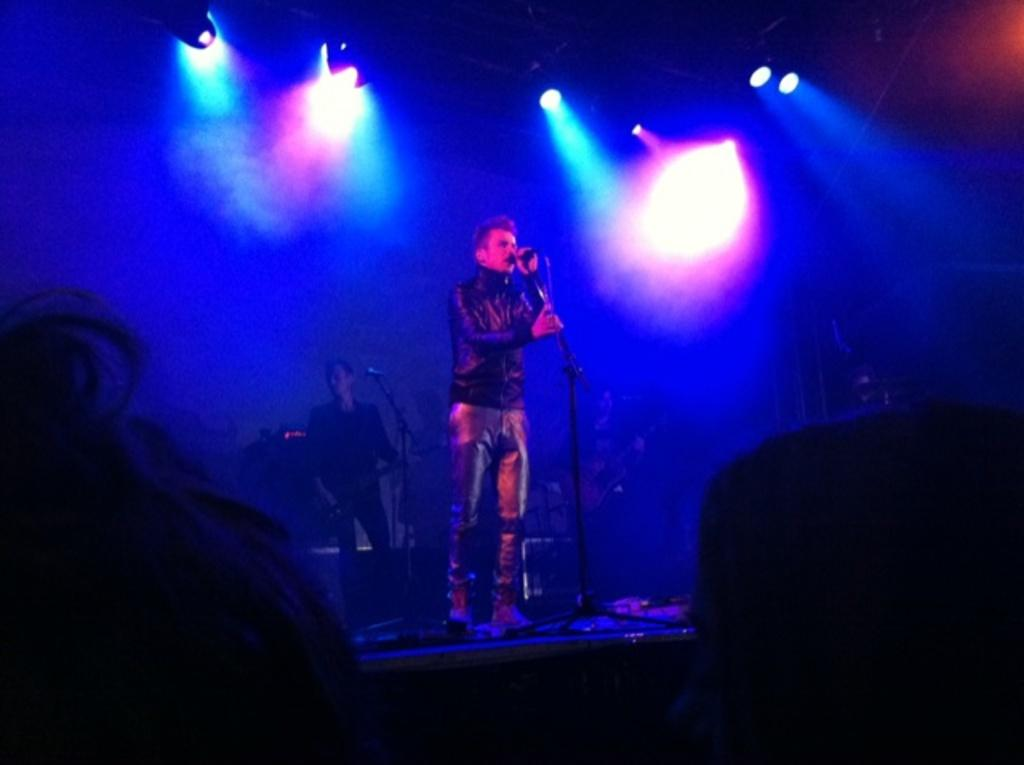How many people are on the stage in the image? There are two men standing on the stage in the image. What objects are present to help amplify sound? Microphones are present in the image. What type of lighting is visible on the stage? Stage lights are visible in the image. How would you describe the lighting conditions in the image? The image is described as being a little bit dark. What type of curtain is used to expand the stage in the image? There is no mention of a curtain in the image, nor is there any indication that the stage is being expanded. 